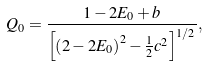Convert formula to latex. <formula><loc_0><loc_0><loc_500><loc_500>Q _ { 0 } = \frac { 1 - 2 E _ { 0 } + b } { \left [ \left ( 2 - 2 E _ { 0 } \right ) ^ { 2 } - \frac { 1 } { 2 } c ^ { 2 } \right ] ^ { 1 / 2 } } ,</formula> 